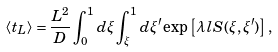Convert formula to latex. <formula><loc_0><loc_0><loc_500><loc_500>\left < t _ { L } \right > = \frac { L ^ { 2 } } { D } \int _ { 0 } ^ { 1 } d \xi \int ^ { 1 } _ { \xi } d \xi ^ { \prime } \exp \left [ \lambda l S ( \xi , \xi ^ { \prime } ) \right ] ,</formula> 